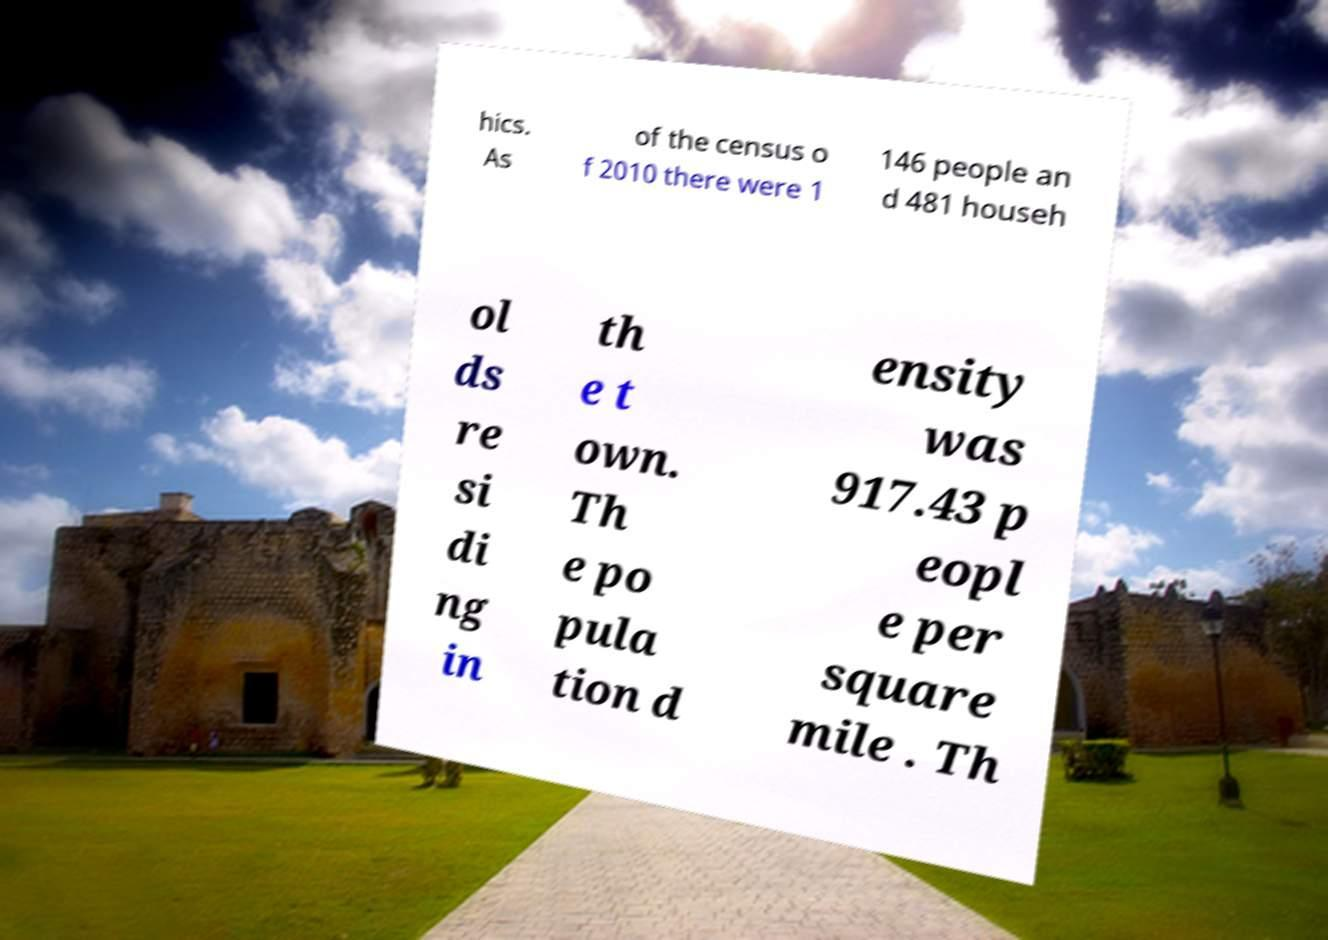Could you extract and type out the text from this image? hics. As of the census o f 2010 there were 1 146 people an d 481 househ ol ds re si di ng in th e t own. Th e po pula tion d ensity was 917.43 p eopl e per square mile . Th 